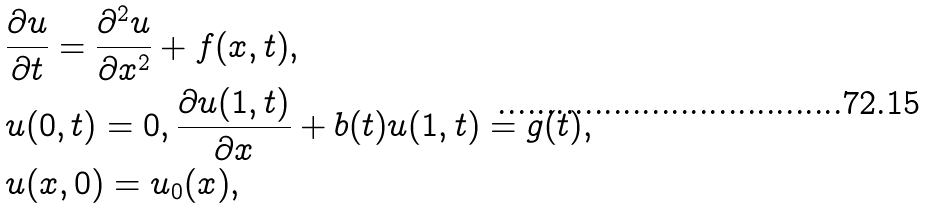<formula> <loc_0><loc_0><loc_500><loc_500>& \frac { \partial u } { \partial t } = \frac { \partial ^ { 2 } u } { \partial x ^ { 2 } } + f ( x , t ) , \\ & u ( 0 , t ) = 0 , \frac { \partial u ( 1 , t ) } { \partial x } + b ( t ) u ( 1 , t ) = g ( t ) , \\ & u ( x , 0 ) = u _ { 0 } ( x ) ,</formula> 